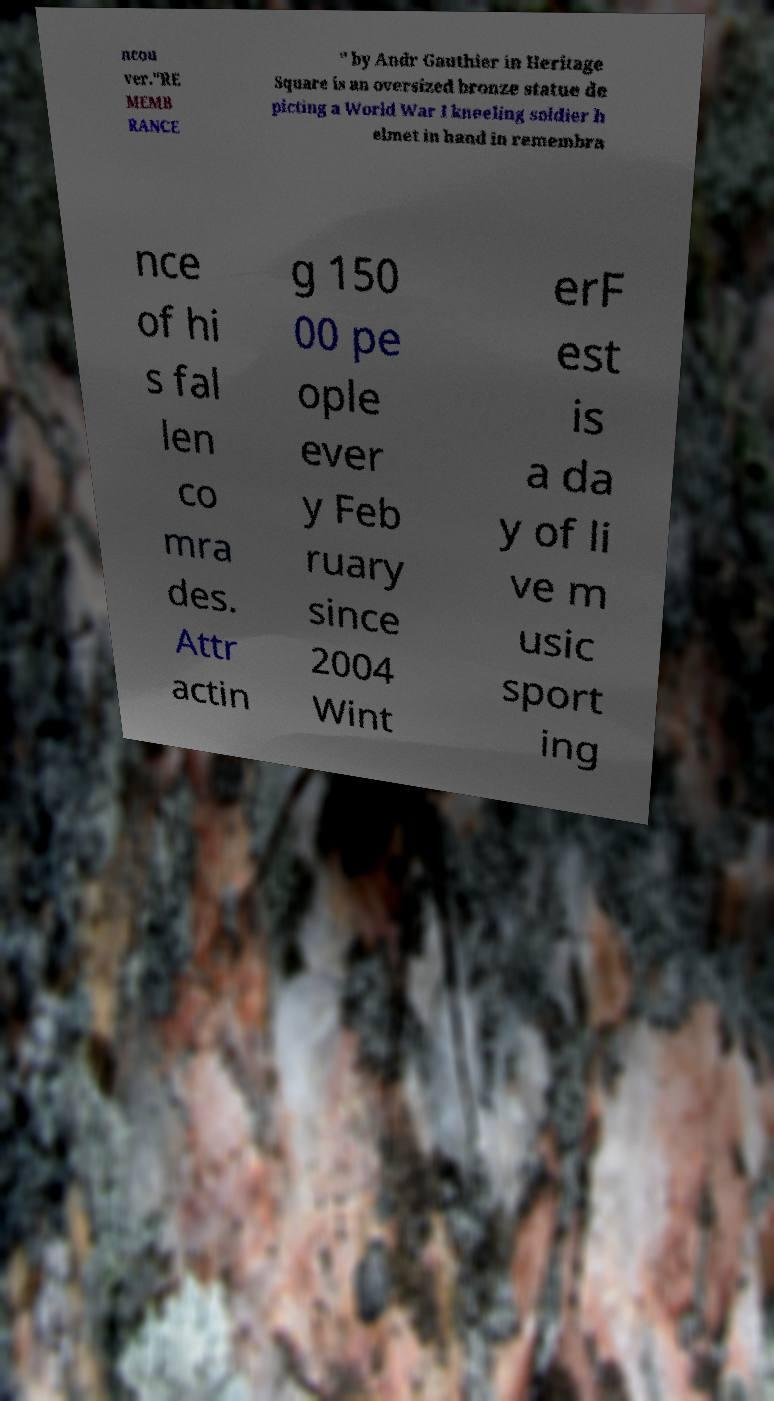For documentation purposes, I need the text within this image transcribed. Could you provide that? ncou ver."RE MEMB RANCE " by Andr Gauthier in Heritage Square is an oversized bronze statue de picting a World War I kneeling soldier h elmet in hand in remembra nce of hi s fal len co mra des. Attr actin g 150 00 pe ople ever y Feb ruary since 2004 Wint erF est is a da y of li ve m usic sport ing 